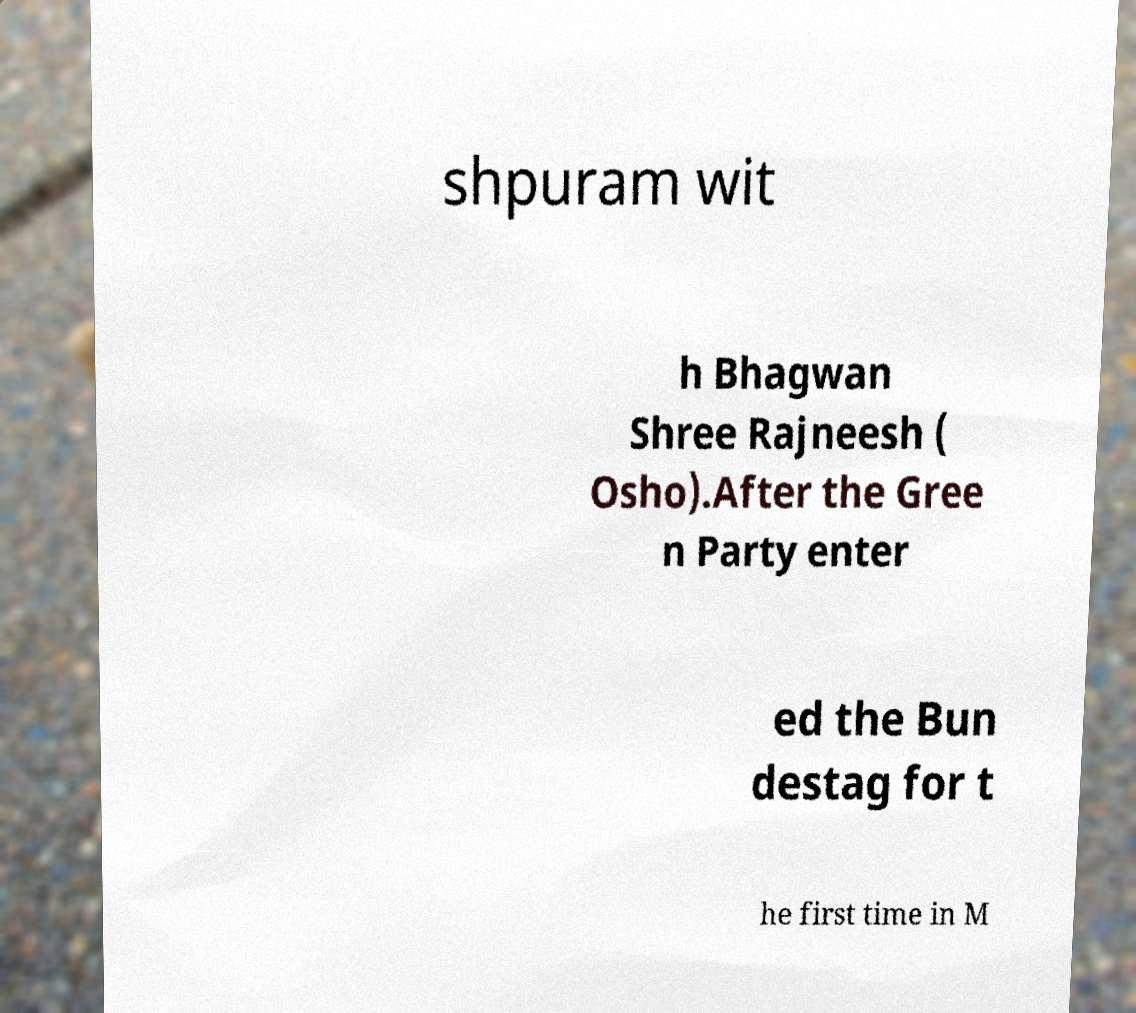Could you assist in decoding the text presented in this image and type it out clearly? shpuram wit h Bhagwan Shree Rajneesh ( Osho).After the Gree n Party enter ed the Bun destag for t he first time in M 